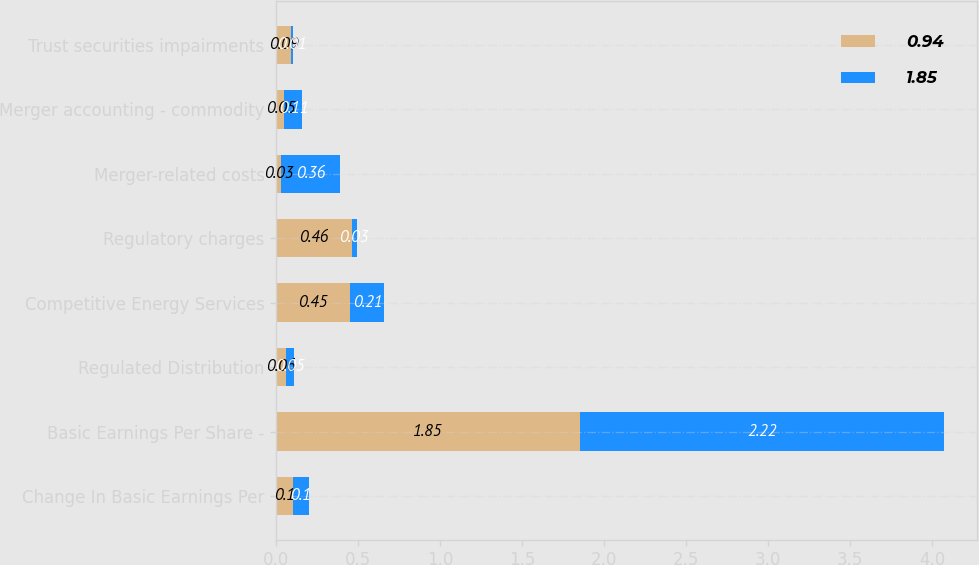Convert chart to OTSL. <chart><loc_0><loc_0><loc_500><loc_500><stacked_bar_chart><ecel><fcel>Change In Basic Earnings Per<fcel>Basic Earnings Per Share -<fcel>Regulated Distribution<fcel>Competitive Energy Services<fcel>Regulatory charges<fcel>Merger-related costs<fcel>Merger accounting - commodity<fcel>Trust securities impairments<nl><fcel>0.94<fcel>0.1<fcel>1.85<fcel>0.06<fcel>0.45<fcel>0.46<fcel>0.03<fcel>0.05<fcel>0.09<nl><fcel>1.85<fcel>0.1<fcel>2.22<fcel>0.05<fcel>0.21<fcel>0.03<fcel>0.36<fcel>0.11<fcel>0.01<nl></chart> 